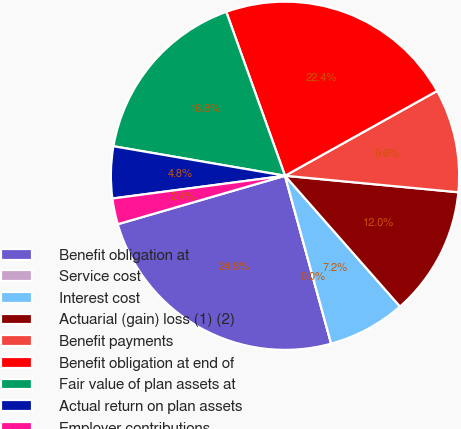Convert chart. <chart><loc_0><loc_0><loc_500><loc_500><pie_chart><fcel>Benefit obligation at<fcel>Service cost<fcel>Interest cost<fcel>Actuarial (gain) loss (1) (2)<fcel>Benefit payments<fcel>Benefit obligation at end of<fcel>Fair value of plan assets at<fcel>Actual return on plan assets<fcel>Employer contributions<nl><fcel>24.78%<fcel>0.0%<fcel>7.21%<fcel>12.01%<fcel>9.61%<fcel>22.38%<fcel>16.81%<fcel>4.8%<fcel>2.4%<nl></chart> 